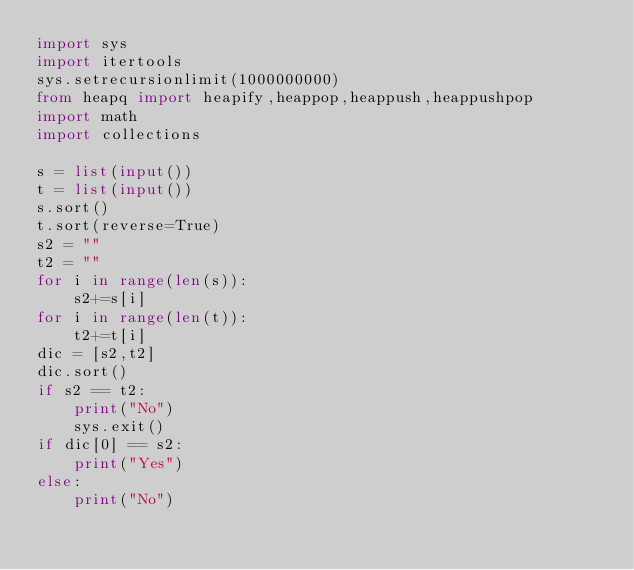<code> <loc_0><loc_0><loc_500><loc_500><_Python_>import sys
import itertools
sys.setrecursionlimit(1000000000)
from heapq import heapify,heappop,heappush,heappushpop
import math
import collections

s = list(input())
t = list(input())
s.sort()
t.sort(reverse=True)
s2 = ""
t2 = ""
for i in range(len(s)):
    s2+=s[i]
for i in range(len(t)):
    t2+=t[i]
dic = [s2,t2]
dic.sort() 
if s2 == t2:
    print("No")
    sys.exit()   
if dic[0] == s2:
    print("Yes")
else:
    print("No")</code> 